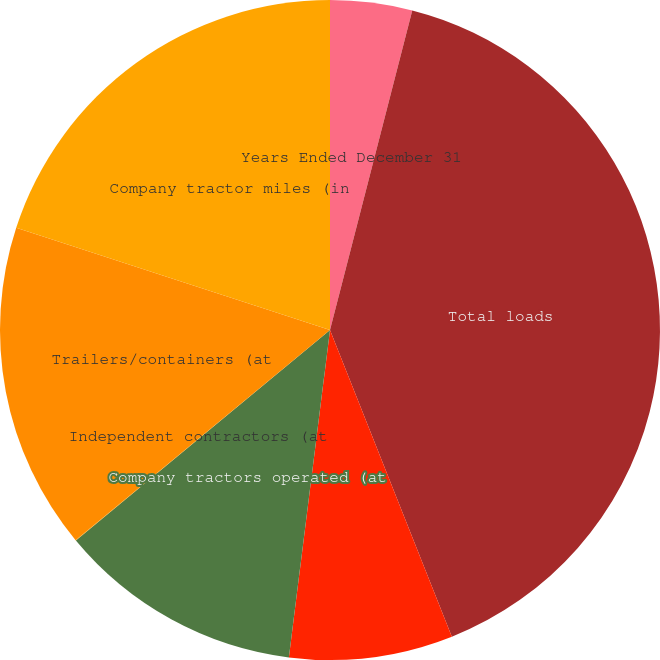Convert chart to OTSL. <chart><loc_0><loc_0><loc_500><loc_500><pie_chart><fcel>Years Ended December 31<fcel>Total loads<fcel>Average number of<fcel>Company tractors operated (at<fcel>Independent contractors (at<fcel>Trailers/containers (at<fcel>Company tractor miles (in<nl><fcel>4.01%<fcel>39.97%<fcel>8.01%<fcel>12.0%<fcel>0.02%<fcel>16.0%<fcel>19.99%<nl></chart> 